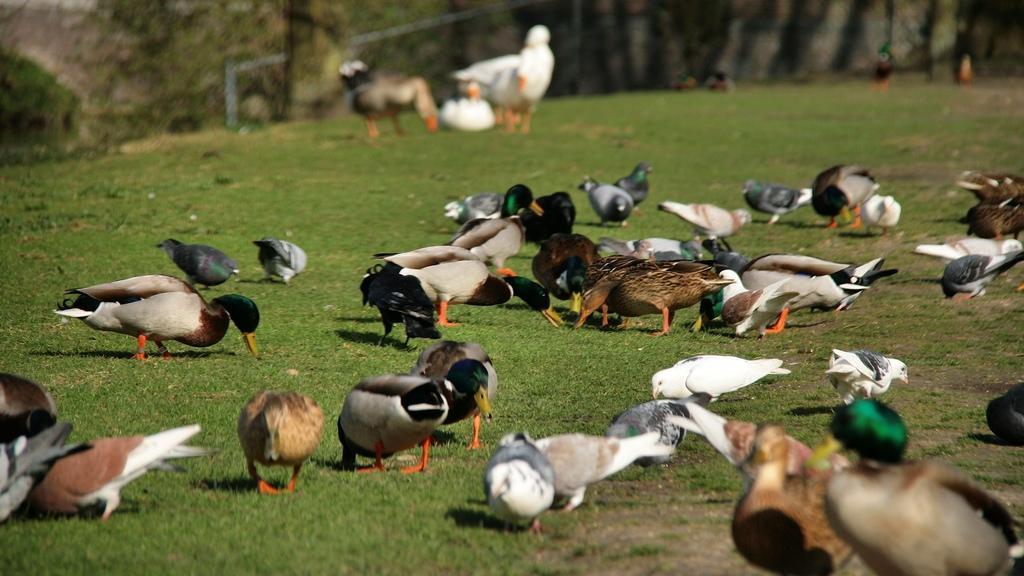Please provide a concise description of this image. In the picture I can see a group of birds on the green grass. It is looking like a trunk of a tree on the top left side of the picture. 